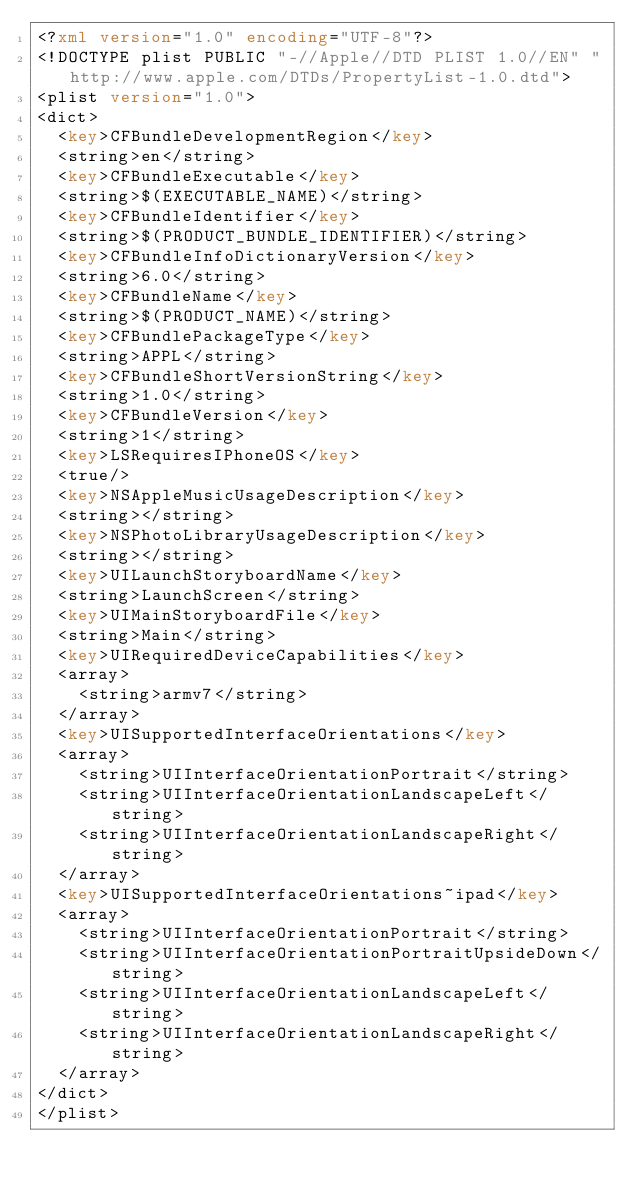<code> <loc_0><loc_0><loc_500><loc_500><_XML_><?xml version="1.0" encoding="UTF-8"?>
<!DOCTYPE plist PUBLIC "-//Apple//DTD PLIST 1.0//EN" "http://www.apple.com/DTDs/PropertyList-1.0.dtd">
<plist version="1.0">
<dict>
	<key>CFBundleDevelopmentRegion</key>
	<string>en</string>
	<key>CFBundleExecutable</key>
	<string>$(EXECUTABLE_NAME)</string>
	<key>CFBundleIdentifier</key>
	<string>$(PRODUCT_BUNDLE_IDENTIFIER)</string>
	<key>CFBundleInfoDictionaryVersion</key>
	<string>6.0</string>
	<key>CFBundleName</key>
	<string>$(PRODUCT_NAME)</string>
	<key>CFBundlePackageType</key>
	<string>APPL</string>
	<key>CFBundleShortVersionString</key>
	<string>1.0</string>
	<key>CFBundleVersion</key>
	<string>1</string>
	<key>LSRequiresIPhoneOS</key>
	<true/>
	<key>NSAppleMusicUsageDescription</key>
	<string></string>
	<key>NSPhotoLibraryUsageDescription</key>
	<string></string>
	<key>UILaunchStoryboardName</key>
	<string>LaunchScreen</string>
	<key>UIMainStoryboardFile</key>
	<string>Main</string>
	<key>UIRequiredDeviceCapabilities</key>
	<array>
		<string>armv7</string>
	</array>
	<key>UISupportedInterfaceOrientations</key>
	<array>
		<string>UIInterfaceOrientationPortrait</string>
		<string>UIInterfaceOrientationLandscapeLeft</string>
		<string>UIInterfaceOrientationLandscapeRight</string>
	</array>
	<key>UISupportedInterfaceOrientations~ipad</key>
	<array>
		<string>UIInterfaceOrientationPortrait</string>
		<string>UIInterfaceOrientationPortraitUpsideDown</string>
		<string>UIInterfaceOrientationLandscapeLeft</string>
		<string>UIInterfaceOrientationLandscapeRight</string>
	</array>
</dict>
</plist>
</code> 